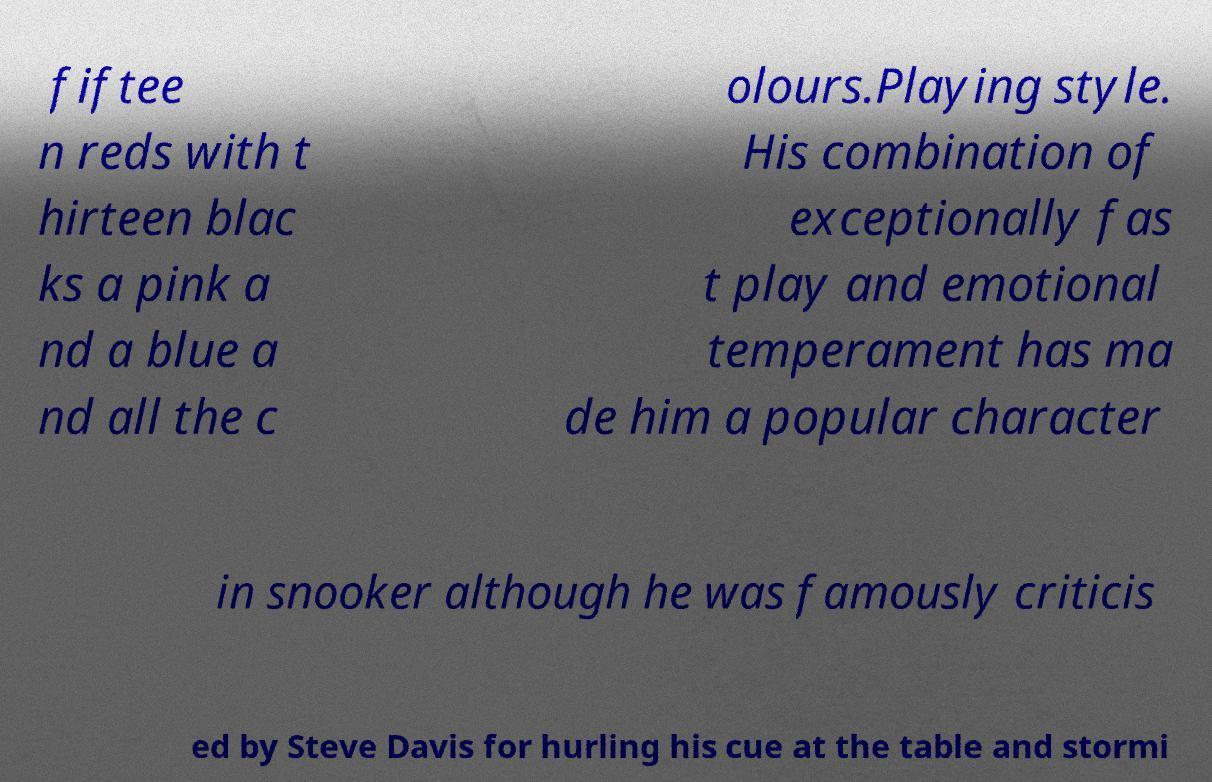What messages or text are displayed in this image? I need them in a readable, typed format. fiftee n reds with t hirteen blac ks a pink a nd a blue a nd all the c olours.Playing style. His combination of exceptionally fas t play and emotional temperament has ma de him a popular character in snooker although he was famously criticis ed by Steve Davis for hurling his cue at the table and stormi 